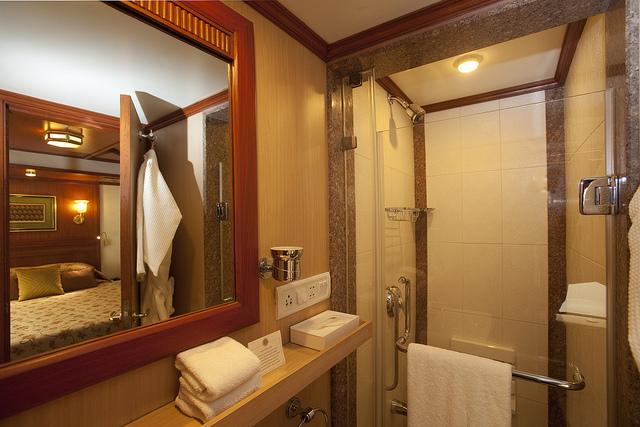Where is the mirror?
Answer briefly. On wall. Is there a shower?
Give a very brief answer. Yes. What type of room is this?
Quick response, please. Bathroom. 